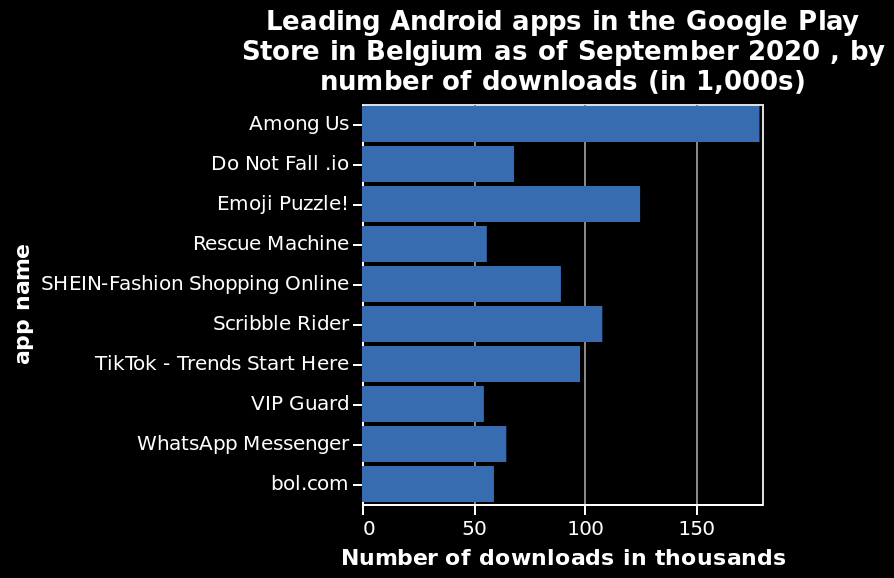<image>
What is the title of the bar chart?  The title of the bar chart is "Leading Android apps in the Google Play Store in Belgium as of September 2020, by number of downloads (in 1,000s)". What type of apps account for several of the most popular apps in 2020? Games account for several of the most popular apps in 2020. 